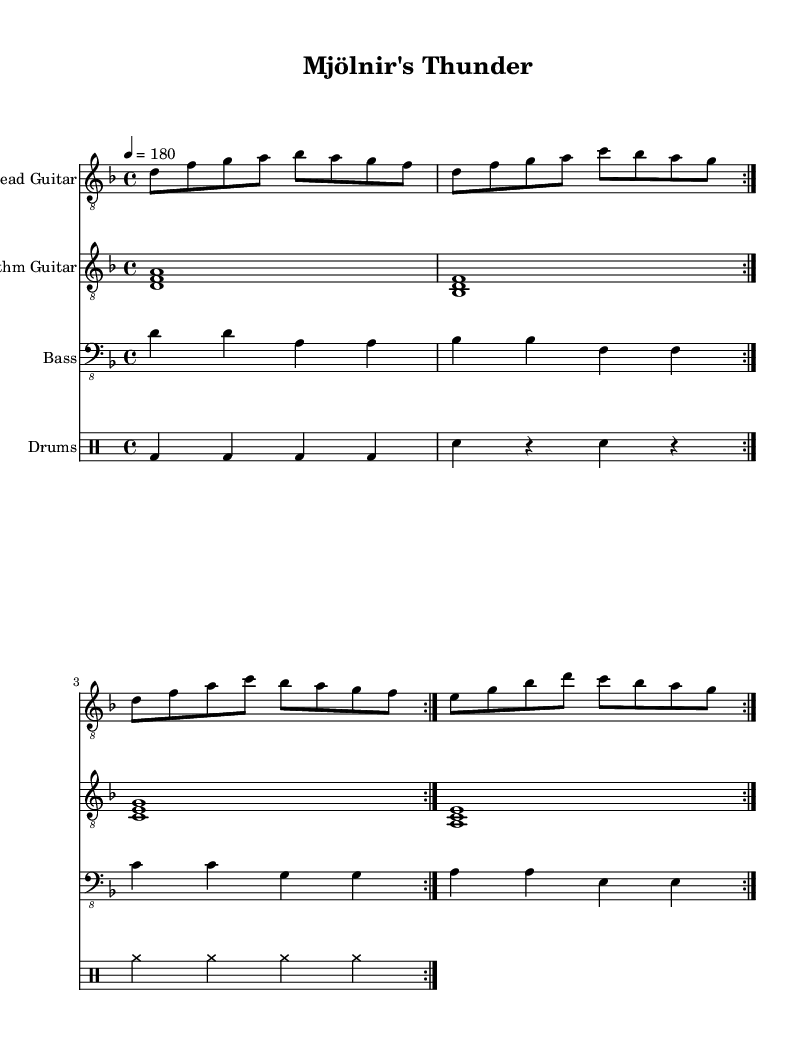What is the key signature of this music? The key signature is indicated by the sharp or flat symbols at the beginning of the staff. In this case, there are no sharps or flats, which identifies the key as D minor.
Answer: D minor What is the time signature of this music? The time signature is shown at the beginning of the score, indicated as "4/4", which means there are four beats in a measure and the quarter note gets one beat.
Answer: 4/4 What is the tempo marking for this piece? The tempo marking is found at the start of the score, indicated as "4 = 180". This means that the tempo is set at 180 beats per minute.
Answer: 180 How many measures are repeated in the lead guitar part? The lead guitar part has a "repeat volta 2" marking that indicates two measures of music are repeated. Counting both sections gives a total of eight measures.
Answer: 8 What chords are used in the rhythm guitar part? The rhythm guitar section shows chord voicings using the notes D, B flat, C, and A, combining each note into triads for each measure.
Answer: D, B flat, C, A What is the drum pattern at the beginning of the piece? The drum part starts with a pattern of bass drum hits on each beat, followed by snare drum hits on the second and fourth beats, and cymbal crashes throughout. Hence, the pattern features alternating strokes of bass and snare.
Answer: Bass and snare What thematic elements are reflected in the title "Mjölnir's Thunder"? The title references Mjölnir, the hammer of Thor, a key weapon in Norse mythology which symbolizes strength and protection. This connects the song's themes of Viking warfare and weaponry directly to Norse culture.
Answer: Norse mythology 